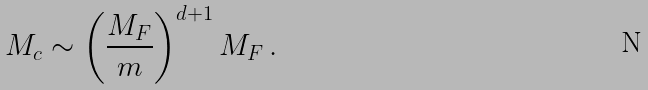<formula> <loc_0><loc_0><loc_500><loc_500>M _ { c } \sim \left ( \frac { M _ { F } } { m } \right ) ^ { d + 1 } M _ { F } \, .</formula> 